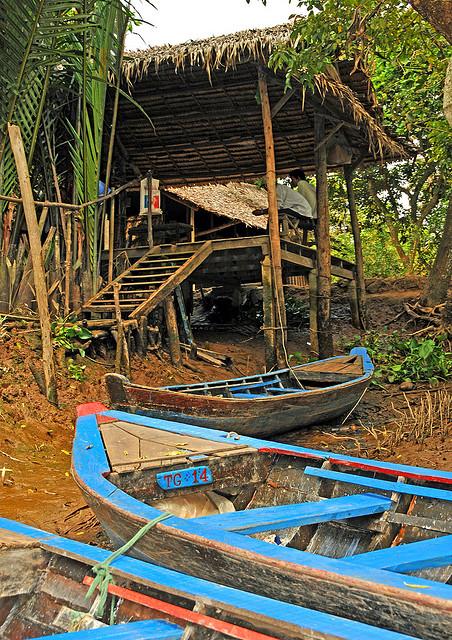What color is the same on each boat?
Answer briefly. Blue. What is written on the boat in the middle?
Be succinct. Tg 14. Is anyone on the boats?
Quick response, please. No. 